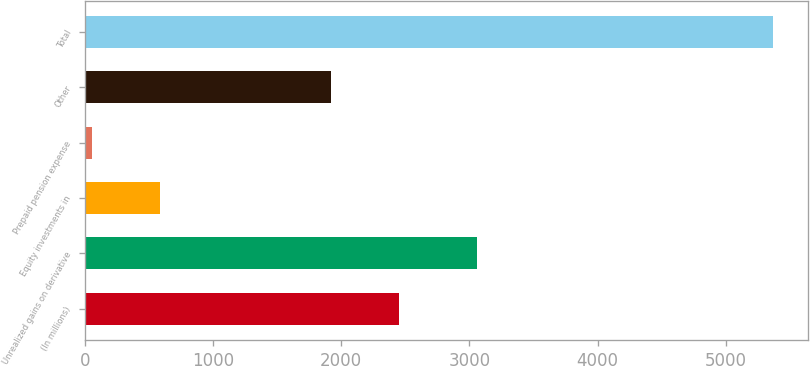Convert chart. <chart><loc_0><loc_0><loc_500><loc_500><bar_chart><fcel>(In millions)<fcel>Unrealized gains on derivative<fcel>Equity investments in<fcel>Prepaid pension expense<fcel>Other<fcel>Total<nl><fcel>2453.8<fcel>3060<fcel>584.8<fcel>53<fcel>1922<fcel>5371<nl></chart> 